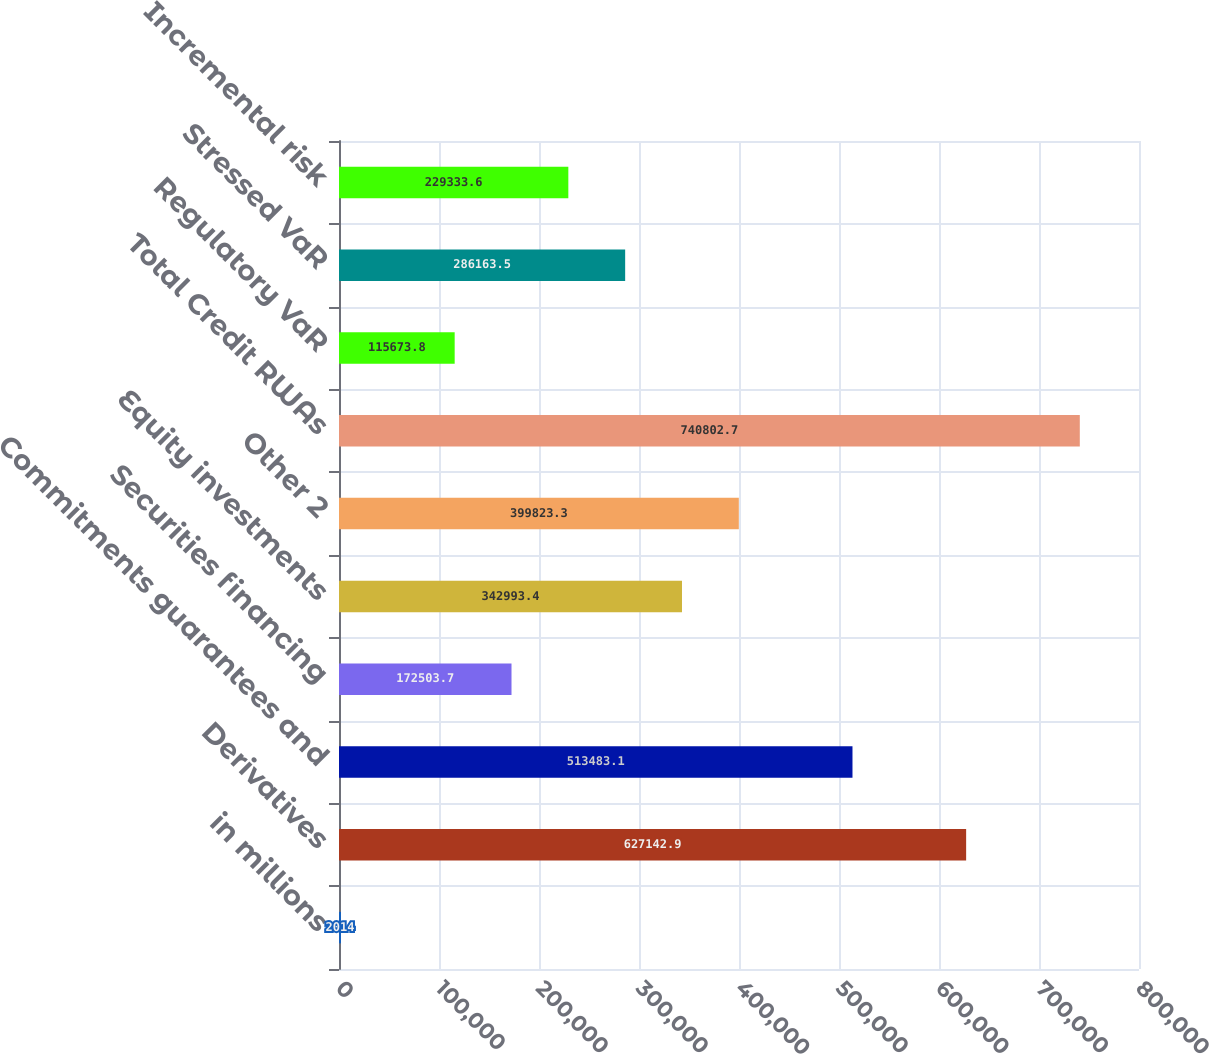<chart> <loc_0><loc_0><loc_500><loc_500><bar_chart><fcel>in millions<fcel>Derivatives<fcel>Commitments guarantees and<fcel>Securities financing<fcel>Equity investments<fcel>Other 2<fcel>Total Credit RWAs<fcel>Regulatory VaR<fcel>Stressed VaR<fcel>Incremental risk<nl><fcel>2014<fcel>627143<fcel>513483<fcel>172504<fcel>342993<fcel>399823<fcel>740803<fcel>115674<fcel>286164<fcel>229334<nl></chart> 